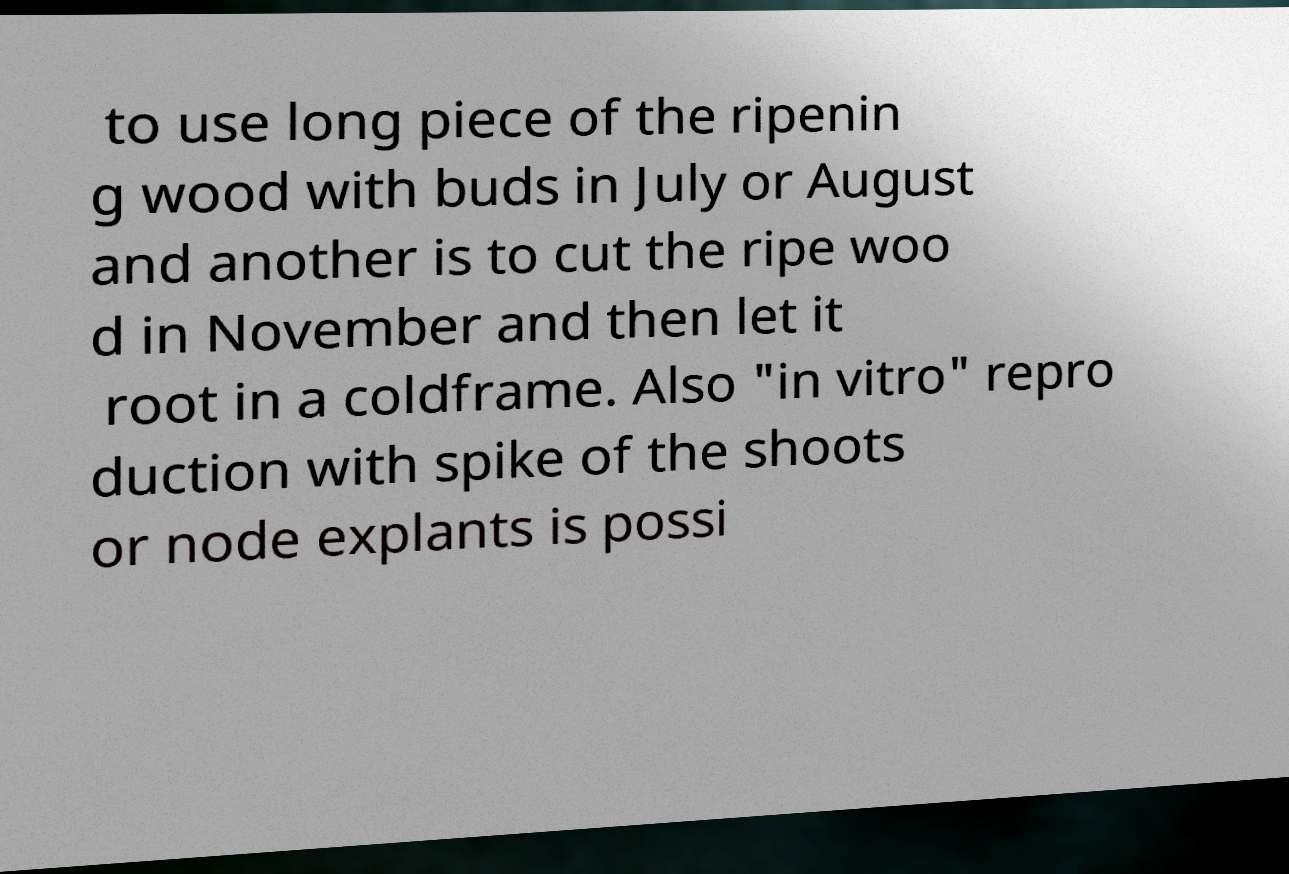What messages or text are displayed in this image? I need them in a readable, typed format. to use long piece of the ripenin g wood with buds in July or August and another is to cut the ripe woo d in November and then let it root in a coldframe. Also "in vitro" repro duction with spike of the shoots or node explants is possi 